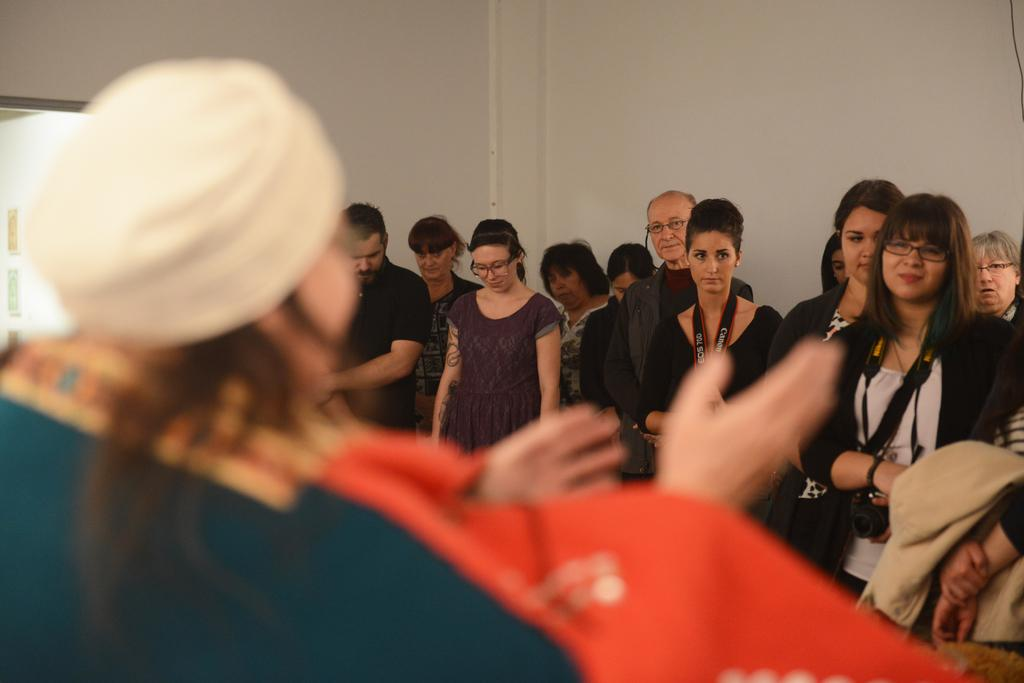What is happening in the image? There are people standing in the image. Can you describe the people in the image? Some of the people are wearing spectacles, and some are holding cameras. What can be seen in the background of the image? There is a wall in the background of the image. How many quinces are being held by the people in the image? There are no quinces present in the image; the people are holding cameras. 